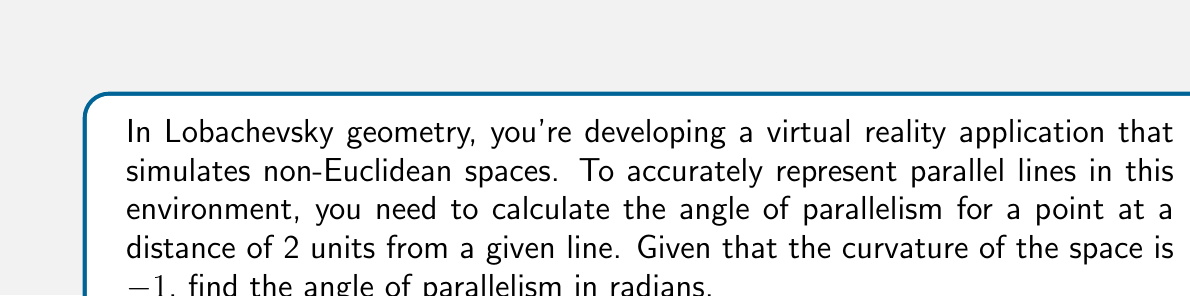Show me your answer to this math problem. To solve this problem, we'll follow these steps:

1) In Lobachevsky geometry, the angle of parallelism $\Pi(x)$ for a point at distance $x$ from a line is given by the formula:

   $$\Pi(x) = 2 \arctan(e^{-x})$$

   where $x$ is the distance and $e$ is Euler's number.

2) We're given that the distance $x = 2$ units and the curvature $k = -1$.

3) Substituting these values into the formula:

   $$\Pi(2) = 2 \arctan(e^{-2})$$

4) Now, let's calculate $e^{-2}$:
   
   $$e^{-2} \approx 0.1353$$

5) Next, we calculate $\arctan(0.1353)$:
   
   $$\arctan(0.1353) \approx 0.1345$$

6) Finally, we multiply this result by 2:
   
   $$2 * 0.1345 \approx 0.2690$$

Therefore, the angle of parallelism is approximately 0.2690 radians.

[asy]
import geometry;

size(200);
pair A = (0,0), B = (100,0), C = (100,50);
draw(A--B, arrow=Arrow(TeXHead));
draw(A--C, arrow=Arrow(TeXHead));
draw(B--C, dashed);
label("$\Pi(x)$", (20,30));
label("$x$", (50,-10));
dot(A);
[/asy]
Answer: $\Pi(2) \approx 0.2690$ radians 